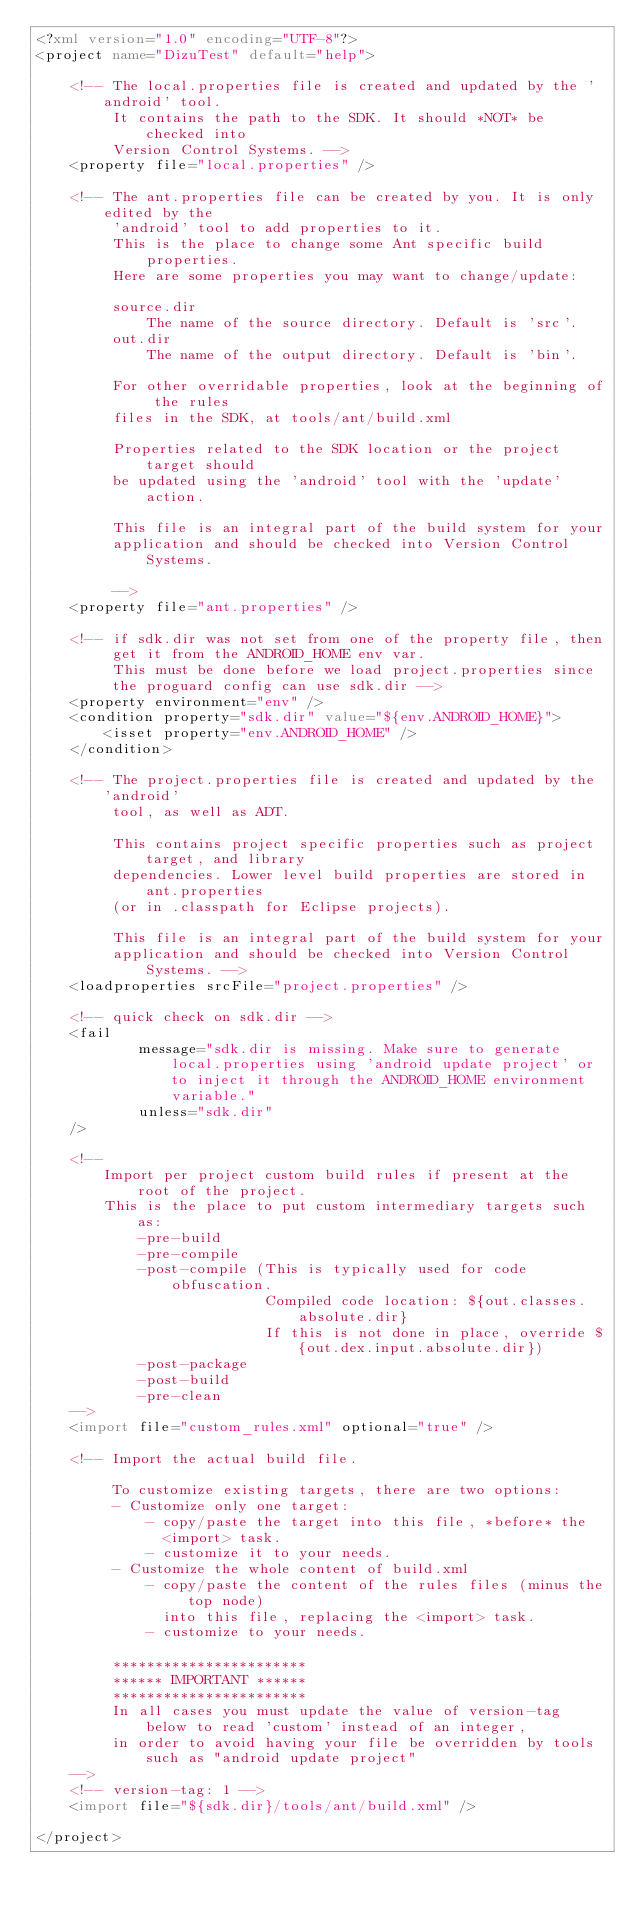Convert code to text. <code><loc_0><loc_0><loc_500><loc_500><_XML_><?xml version="1.0" encoding="UTF-8"?>
<project name="DizuTest" default="help">

    <!-- The local.properties file is created and updated by the 'android' tool.
         It contains the path to the SDK. It should *NOT* be checked into
         Version Control Systems. -->
    <property file="local.properties" />

    <!-- The ant.properties file can be created by you. It is only edited by the
         'android' tool to add properties to it.
         This is the place to change some Ant specific build properties.
         Here are some properties you may want to change/update:

         source.dir
             The name of the source directory. Default is 'src'.
         out.dir
             The name of the output directory. Default is 'bin'.

         For other overridable properties, look at the beginning of the rules
         files in the SDK, at tools/ant/build.xml

         Properties related to the SDK location or the project target should
         be updated using the 'android' tool with the 'update' action.

         This file is an integral part of the build system for your
         application and should be checked into Version Control Systems.

         -->
    <property file="ant.properties" />

    <!-- if sdk.dir was not set from one of the property file, then
         get it from the ANDROID_HOME env var.
         This must be done before we load project.properties since
         the proguard config can use sdk.dir -->
    <property environment="env" />
    <condition property="sdk.dir" value="${env.ANDROID_HOME}">
        <isset property="env.ANDROID_HOME" />
    </condition>

    <!-- The project.properties file is created and updated by the 'android'
         tool, as well as ADT.

         This contains project specific properties such as project target, and library
         dependencies. Lower level build properties are stored in ant.properties
         (or in .classpath for Eclipse projects).

         This file is an integral part of the build system for your
         application and should be checked into Version Control Systems. -->
    <loadproperties srcFile="project.properties" />

    <!-- quick check on sdk.dir -->
    <fail
            message="sdk.dir is missing. Make sure to generate local.properties using 'android update project' or to inject it through the ANDROID_HOME environment variable."
            unless="sdk.dir"
    />

    <!--
        Import per project custom build rules if present at the root of the project.
        This is the place to put custom intermediary targets such as:
            -pre-build
            -pre-compile
            -post-compile (This is typically used for code obfuscation.
                           Compiled code location: ${out.classes.absolute.dir}
                           If this is not done in place, override ${out.dex.input.absolute.dir})
            -post-package
            -post-build
            -pre-clean
    -->
    <import file="custom_rules.xml" optional="true" />

    <!-- Import the actual build file.

         To customize existing targets, there are two options:
         - Customize only one target:
             - copy/paste the target into this file, *before* the
               <import> task.
             - customize it to your needs.
         - Customize the whole content of build.xml
             - copy/paste the content of the rules files (minus the top node)
               into this file, replacing the <import> task.
             - customize to your needs.

         ***********************
         ****** IMPORTANT ******
         ***********************
         In all cases you must update the value of version-tag below to read 'custom' instead of an integer,
         in order to avoid having your file be overridden by tools such as "android update project"
    -->
    <!-- version-tag: 1 -->
    <import file="${sdk.dir}/tools/ant/build.xml" />

</project>
</code> 